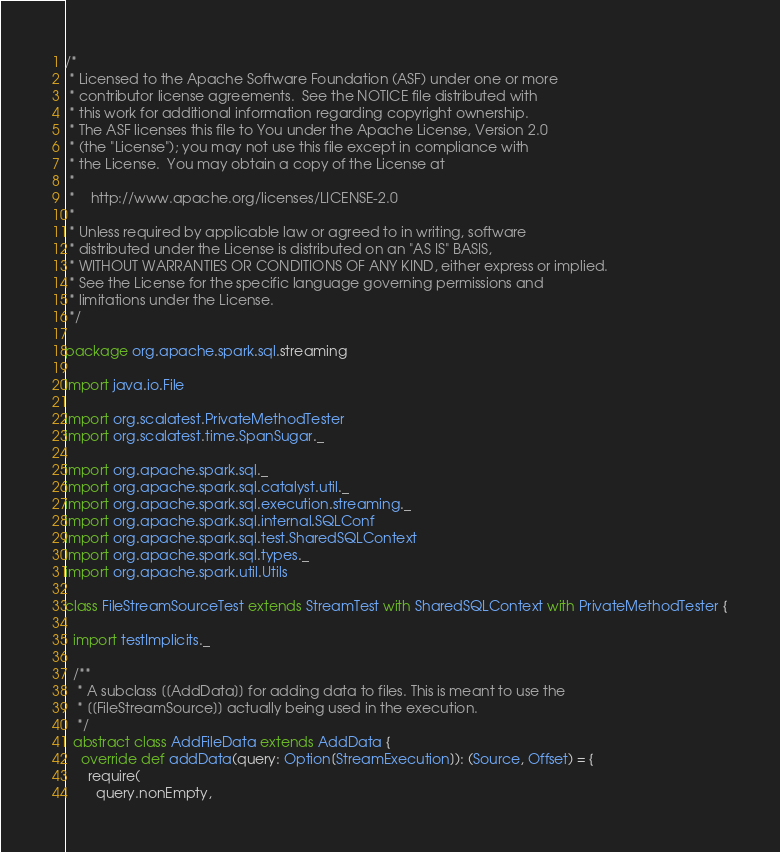Convert code to text. <code><loc_0><loc_0><loc_500><loc_500><_Scala_>/*
 * Licensed to the Apache Software Foundation (ASF) under one or more
 * contributor license agreements.  See the NOTICE file distributed with
 * this work for additional information regarding copyright ownership.
 * The ASF licenses this file to You under the Apache License, Version 2.0
 * (the "License"); you may not use this file except in compliance with
 * the License.  You may obtain a copy of the License at
 *
 *    http://www.apache.org/licenses/LICENSE-2.0
 *
 * Unless required by applicable law or agreed to in writing, software
 * distributed under the License is distributed on an "AS IS" BASIS,
 * WITHOUT WARRANTIES OR CONDITIONS OF ANY KIND, either express or implied.
 * See the License for the specific language governing permissions and
 * limitations under the License.
 */

package org.apache.spark.sql.streaming

import java.io.File

import org.scalatest.PrivateMethodTester
import org.scalatest.time.SpanSugar._

import org.apache.spark.sql._
import org.apache.spark.sql.catalyst.util._
import org.apache.spark.sql.execution.streaming._
import org.apache.spark.sql.internal.SQLConf
import org.apache.spark.sql.test.SharedSQLContext
import org.apache.spark.sql.types._
import org.apache.spark.util.Utils

class FileStreamSourceTest extends StreamTest with SharedSQLContext with PrivateMethodTester {

  import testImplicits._

  /**
   * A subclass [[AddData]] for adding data to files. This is meant to use the
   * [[FileStreamSource]] actually being used in the execution.
   */
  abstract class AddFileData extends AddData {
    override def addData(query: Option[StreamExecution]): (Source, Offset) = {
      require(
        query.nonEmpty,</code> 